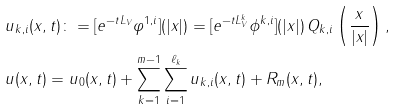Convert formula to latex. <formula><loc_0><loc_0><loc_500><loc_500>& u _ { k , i } ( x , t ) \colon = [ e ^ { - t L _ { V } } \varphi ^ { 1 , i } ] ( | x | ) = [ e ^ { - t L _ { V } ^ { k } } \phi ^ { k , i } ] ( | x | ) \, Q _ { k , i } \left ( \frac { x } { | x | } \right ) , \\ & u ( x , t ) = u _ { 0 } ( x , t ) + \sum _ { k = 1 } ^ { m - 1 } \sum _ { i = 1 } ^ { \ell _ { k } } u _ { k , i } ( x , t ) + R _ { m } ( x , t ) ,</formula> 